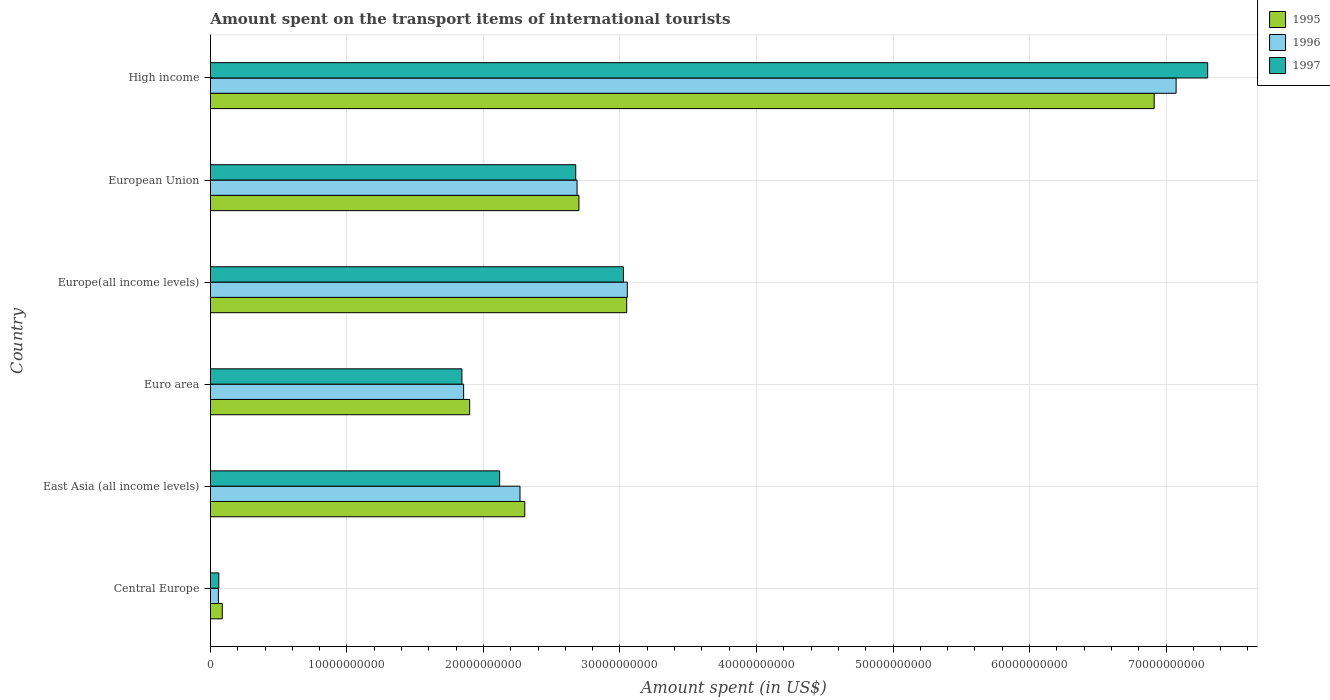Are the number of bars per tick equal to the number of legend labels?
Your response must be concise. Yes. How many bars are there on the 5th tick from the top?
Make the answer very short. 3. What is the label of the 5th group of bars from the top?
Your response must be concise. East Asia (all income levels). What is the amount spent on the transport items of international tourists in 1997 in Europe(all income levels)?
Keep it short and to the point. 3.03e+1. Across all countries, what is the maximum amount spent on the transport items of international tourists in 1996?
Give a very brief answer. 7.07e+1. Across all countries, what is the minimum amount spent on the transport items of international tourists in 1996?
Your answer should be compact. 5.81e+08. In which country was the amount spent on the transport items of international tourists in 1997 maximum?
Your answer should be compact. High income. In which country was the amount spent on the transport items of international tourists in 1996 minimum?
Your answer should be very brief. Central Europe. What is the total amount spent on the transport items of international tourists in 1995 in the graph?
Keep it short and to the point. 1.69e+11. What is the difference between the amount spent on the transport items of international tourists in 1995 in Europe(all income levels) and that in European Union?
Offer a very short reply. 3.50e+09. What is the difference between the amount spent on the transport items of international tourists in 1997 in Euro area and the amount spent on the transport items of international tourists in 1995 in High income?
Give a very brief answer. -5.07e+1. What is the average amount spent on the transport items of international tourists in 1997 per country?
Provide a short and direct response. 2.84e+1. What is the difference between the amount spent on the transport items of international tourists in 1997 and amount spent on the transport items of international tourists in 1996 in Europe(all income levels)?
Ensure brevity in your answer.  -2.85e+08. In how many countries, is the amount spent on the transport items of international tourists in 1997 greater than 48000000000 US$?
Your response must be concise. 1. What is the ratio of the amount spent on the transport items of international tourists in 1997 in Central Europe to that in High income?
Ensure brevity in your answer.  0.01. What is the difference between the highest and the second highest amount spent on the transport items of international tourists in 1995?
Offer a terse response. 3.86e+1. What is the difference between the highest and the lowest amount spent on the transport items of international tourists in 1996?
Your response must be concise. 7.02e+1. In how many countries, is the amount spent on the transport items of international tourists in 1997 greater than the average amount spent on the transport items of international tourists in 1997 taken over all countries?
Your answer should be compact. 2. What does the 2nd bar from the bottom in East Asia (all income levels) represents?
Your answer should be very brief. 1996. How many bars are there?
Ensure brevity in your answer.  18. How many countries are there in the graph?
Make the answer very short. 6. What is the difference between two consecutive major ticks on the X-axis?
Give a very brief answer. 1.00e+1. Does the graph contain any zero values?
Provide a succinct answer. No. Where does the legend appear in the graph?
Offer a terse response. Top right. How many legend labels are there?
Provide a short and direct response. 3. What is the title of the graph?
Keep it short and to the point. Amount spent on the transport items of international tourists. Does "1999" appear as one of the legend labels in the graph?
Give a very brief answer. No. What is the label or title of the X-axis?
Keep it short and to the point. Amount spent (in US$). What is the label or title of the Y-axis?
Ensure brevity in your answer.  Country. What is the Amount spent (in US$) in 1995 in Central Europe?
Offer a terse response. 8.65e+08. What is the Amount spent (in US$) of 1996 in Central Europe?
Offer a very short reply. 5.81e+08. What is the Amount spent (in US$) in 1997 in Central Europe?
Make the answer very short. 6.10e+08. What is the Amount spent (in US$) in 1995 in East Asia (all income levels)?
Give a very brief answer. 2.30e+1. What is the Amount spent (in US$) of 1996 in East Asia (all income levels)?
Your response must be concise. 2.27e+1. What is the Amount spent (in US$) in 1997 in East Asia (all income levels)?
Your response must be concise. 2.12e+1. What is the Amount spent (in US$) in 1995 in Euro area?
Offer a terse response. 1.90e+1. What is the Amount spent (in US$) in 1996 in Euro area?
Make the answer very short. 1.85e+1. What is the Amount spent (in US$) in 1997 in Euro area?
Keep it short and to the point. 1.84e+1. What is the Amount spent (in US$) of 1995 in Europe(all income levels)?
Your answer should be very brief. 3.05e+1. What is the Amount spent (in US$) in 1996 in Europe(all income levels)?
Offer a very short reply. 3.05e+1. What is the Amount spent (in US$) of 1997 in Europe(all income levels)?
Your answer should be very brief. 3.03e+1. What is the Amount spent (in US$) of 1995 in European Union?
Your answer should be compact. 2.70e+1. What is the Amount spent (in US$) in 1996 in European Union?
Ensure brevity in your answer.  2.69e+1. What is the Amount spent (in US$) of 1997 in European Union?
Your answer should be very brief. 2.68e+1. What is the Amount spent (in US$) of 1995 in High income?
Your answer should be very brief. 6.91e+1. What is the Amount spent (in US$) of 1996 in High income?
Provide a succinct answer. 7.07e+1. What is the Amount spent (in US$) in 1997 in High income?
Your response must be concise. 7.31e+1. Across all countries, what is the maximum Amount spent (in US$) in 1995?
Your answer should be compact. 6.91e+1. Across all countries, what is the maximum Amount spent (in US$) in 1996?
Give a very brief answer. 7.07e+1. Across all countries, what is the maximum Amount spent (in US$) in 1997?
Offer a very short reply. 7.31e+1. Across all countries, what is the minimum Amount spent (in US$) of 1995?
Your answer should be very brief. 8.65e+08. Across all countries, what is the minimum Amount spent (in US$) of 1996?
Make the answer very short. 5.81e+08. Across all countries, what is the minimum Amount spent (in US$) of 1997?
Offer a very short reply. 6.10e+08. What is the total Amount spent (in US$) of 1995 in the graph?
Provide a succinct answer. 1.69e+11. What is the total Amount spent (in US$) of 1996 in the graph?
Provide a succinct answer. 1.70e+11. What is the total Amount spent (in US$) of 1997 in the graph?
Provide a short and direct response. 1.70e+11. What is the difference between the Amount spent (in US$) in 1995 in Central Europe and that in East Asia (all income levels)?
Your answer should be compact. -2.22e+1. What is the difference between the Amount spent (in US$) of 1996 in Central Europe and that in East Asia (all income levels)?
Your response must be concise. -2.21e+1. What is the difference between the Amount spent (in US$) in 1997 in Central Europe and that in East Asia (all income levels)?
Provide a succinct answer. -2.06e+1. What is the difference between the Amount spent (in US$) in 1995 in Central Europe and that in Euro area?
Ensure brevity in your answer.  -1.81e+1. What is the difference between the Amount spent (in US$) in 1996 in Central Europe and that in Euro area?
Your answer should be compact. -1.80e+1. What is the difference between the Amount spent (in US$) of 1997 in Central Europe and that in Euro area?
Your response must be concise. -1.78e+1. What is the difference between the Amount spent (in US$) of 1995 in Central Europe and that in Europe(all income levels)?
Give a very brief answer. -2.96e+1. What is the difference between the Amount spent (in US$) in 1996 in Central Europe and that in Europe(all income levels)?
Offer a very short reply. -3.00e+1. What is the difference between the Amount spent (in US$) in 1997 in Central Europe and that in Europe(all income levels)?
Provide a short and direct response. -2.96e+1. What is the difference between the Amount spent (in US$) of 1995 in Central Europe and that in European Union?
Provide a short and direct response. -2.61e+1. What is the difference between the Amount spent (in US$) in 1996 in Central Europe and that in European Union?
Provide a short and direct response. -2.63e+1. What is the difference between the Amount spent (in US$) of 1997 in Central Europe and that in European Union?
Provide a short and direct response. -2.61e+1. What is the difference between the Amount spent (in US$) of 1995 in Central Europe and that in High income?
Your answer should be compact. -6.83e+1. What is the difference between the Amount spent (in US$) in 1996 in Central Europe and that in High income?
Your answer should be compact. -7.02e+1. What is the difference between the Amount spent (in US$) of 1997 in Central Europe and that in High income?
Your answer should be compact. -7.24e+1. What is the difference between the Amount spent (in US$) of 1995 in East Asia (all income levels) and that in Euro area?
Your answer should be very brief. 4.04e+09. What is the difference between the Amount spent (in US$) of 1996 in East Asia (all income levels) and that in Euro area?
Offer a terse response. 4.13e+09. What is the difference between the Amount spent (in US$) in 1997 in East Asia (all income levels) and that in Euro area?
Make the answer very short. 2.76e+09. What is the difference between the Amount spent (in US$) in 1995 in East Asia (all income levels) and that in Europe(all income levels)?
Provide a short and direct response. -7.47e+09. What is the difference between the Amount spent (in US$) of 1996 in East Asia (all income levels) and that in Europe(all income levels)?
Your answer should be very brief. -7.86e+09. What is the difference between the Amount spent (in US$) of 1997 in East Asia (all income levels) and that in Europe(all income levels)?
Make the answer very short. -9.07e+09. What is the difference between the Amount spent (in US$) of 1995 in East Asia (all income levels) and that in European Union?
Ensure brevity in your answer.  -3.97e+09. What is the difference between the Amount spent (in US$) of 1996 in East Asia (all income levels) and that in European Union?
Provide a short and direct response. -4.18e+09. What is the difference between the Amount spent (in US$) of 1997 in East Asia (all income levels) and that in European Union?
Make the answer very short. -5.57e+09. What is the difference between the Amount spent (in US$) in 1995 in East Asia (all income levels) and that in High income?
Your response must be concise. -4.61e+1. What is the difference between the Amount spent (in US$) in 1996 in East Asia (all income levels) and that in High income?
Make the answer very short. -4.81e+1. What is the difference between the Amount spent (in US$) in 1997 in East Asia (all income levels) and that in High income?
Ensure brevity in your answer.  -5.19e+1. What is the difference between the Amount spent (in US$) of 1995 in Euro area and that in Europe(all income levels)?
Provide a succinct answer. -1.15e+1. What is the difference between the Amount spent (in US$) of 1996 in Euro area and that in Europe(all income levels)?
Provide a succinct answer. -1.20e+1. What is the difference between the Amount spent (in US$) in 1997 in Euro area and that in Europe(all income levels)?
Keep it short and to the point. -1.18e+1. What is the difference between the Amount spent (in US$) in 1995 in Euro area and that in European Union?
Make the answer very short. -8.01e+09. What is the difference between the Amount spent (in US$) in 1996 in Euro area and that in European Union?
Give a very brief answer. -8.31e+09. What is the difference between the Amount spent (in US$) in 1997 in Euro area and that in European Union?
Your response must be concise. -8.34e+09. What is the difference between the Amount spent (in US$) in 1995 in Euro area and that in High income?
Offer a terse response. -5.01e+1. What is the difference between the Amount spent (in US$) in 1996 in Euro area and that in High income?
Your response must be concise. -5.22e+1. What is the difference between the Amount spent (in US$) of 1997 in Euro area and that in High income?
Your response must be concise. -5.46e+1. What is the difference between the Amount spent (in US$) in 1995 in Europe(all income levels) and that in European Union?
Give a very brief answer. 3.50e+09. What is the difference between the Amount spent (in US$) in 1996 in Europe(all income levels) and that in European Union?
Ensure brevity in your answer.  3.68e+09. What is the difference between the Amount spent (in US$) in 1997 in Europe(all income levels) and that in European Union?
Offer a very short reply. 3.49e+09. What is the difference between the Amount spent (in US$) in 1995 in Europe(all income levels) and that in High income?
Your answer should be very brief. -3.86e+1. What is the difference between the Amount spent (in US$) in 1996 in Europe(all income levels) and that in High income?
Your response must be concise. -4.02e+1. What is the difference between the Amount spent (in US$) in 1997 in Europe(all income levels) and that in High income?
Your response must be concise. -4.28e+1. What is the difference between the Amount spent (in US$) of 1995 in European Union and that in High income?
Keep it short and to the point. -4.21e+1. What is the difference between the Amount spent (in US$) in 1996 in European Union and that in High income?
Make the answer very short. -4.39e+1. What is the difference between the Amount spent (in US$) of 1997 in European Union and that in High income?
Offer a terse response. -4.63e+1. What is the difference between the Amount spent (in US$) of 1995 in Central Europe and the Amount spent (in US$) of 1996 in East Asia (all income levels)?
Your answer should be very brief. -2.18e+1. What is the difference between the Amount spent (in US$) in 1995 in Central Europe and the Amount spent (in US$) in 1997 in East Asia (all income levels)?
Keep it short and to the point. -2.03e+1. What is the difference between the Amount spent (in US$) in 1996 in Central Europe and the Amount spent (in US$) in 1997 in East Asia (all income levels)?
Give a very brief answer. -2.06e+1. What is the difference between the Amount spent (in US$) in 1995 in Central Europe and the Amount spent (in US$) in 1996 in Euro area?
Your answer should be very brief. -1.77e+1. What is the difference between the Amount spent (in US$) of 1995 in Central Europe and the Amount spent (in US$) of 1997 in Euro area?
Give a very brief answer. -1.76e+1. What is the difference between the Amount spent (in US$) of 1996 in Central Europe and the Amount spent (in US$) of 1997 in Euro area?
Give a very brief answer. -1.78e+1. What is the difference between the Amount spent (in US$) in 1995 in Central Europe and the Amount spent (in US$) in 1996 in Europe(all income levels)?
Offer a terse response. -2.97e+1. What is the difference between the Amount spent (in US$) of 1995 in Central Europe and the Amount spent (in US$) of 1997 in Europe(all income levels)?
Your response must be concise. -2.94e+1. What is the difference between the Amount spent (in US$) in 1996 in Central Europe and the Amount spent (in US$) in 1997 in Europe(all income levels)?
Keep it short and to the point. -2.97e+1. What is the difference between the Amount spent (in US$) of 1995 in Central Europe and the Amount spent (in US$) of 1996 in European Union?
Provide a short and direct response. -2.60e+1. What is the difference between the Amount spent (in US$) in 1995 in Central Europe and the Amount spent (in US$) in 1997 in European Union?
Your response must be concise. -2.59e+1. What is the difference between the Amount spent (in US$) in 1996 in Central Europe and the Amount spent (in US$) in 1997 in European Union?
Keep it short and to the point. -2.62e+1. What is the difference between the Amount spent (in US$) of 1995 in Central Europe and the Amount spent (in US$) of 1996 in High income?
Give a very brief answer. -6.99e+1. What is the difference between the Amount spent (in US$) in 1995 in Central Europe and the Amount spent (in US$) in 1997 in High income?
Offer a terse response. -7.22e+1. What is the difference between the Amount spent (in US$) of 1996 in Central Europe and the Amount spent (in US$) of 1997 in High income?
Provide a short and direct response. -7.25e+1. What is the difference between the Amount spent (in US$) of 1995 in East Asia (all income levels) and the Amount spent (in US$) of 1996 in Euro area?
Make the answer very short. 4.48e+09. What is the difference between the Amount spent (in US$) of 1995 in East Asia (all income levels) and the Amount spent (in US$) of 1997 in Euro area?
Offer a very short reply. 4.61e+09. What is the difference between the Amount spent (in US$) of 1996 in East Asia (all income levels) and the Amount spent (in US$) of 1997 in Euro area?
Offer a terse response. 4.26e+09. What is the difference between the Amount spent (in US$) of 1995 in East Asia (all income levels) and the Amount spent (in US$) of 1996 in Europe(all income levels)?
Give a very brief answer. -7.51e+09. What is the difference between the Amount spent (in US$) of 1995 in East Asia (all income levels) and the Amount spent (in US$) of 1997 in Europe(all income levels)?
Keep it short and to the point. -7.23e+09. What is the difference between the Amount spent (in US$) in 1996 in East Asia (all income levels) and the Amount spent (in US$) in 1997 in Europe(all income levels)?
Keep it short and to the point. -7.58e+09. What is the difference between the Amount spent (in US$) of 1995 in East Asia (all income levels) and the Amount spent (in US$) of 1996 in European Union?
Give a very brief answer. -3.83e+09. What is the difference between the Amount spent (in US$) of 1995 in East Asia (all income levels) and the Amount spent (in US$) of 1997 in European Union?
Your answer should be compact. -3.73e+09. What is the difference between the Amount spent (in US$) of 1996 in East Asia (all income levels) and the Amount spent (in US$) of 1997 in European Union?
Provide a short and direct response. -4.08e+09. What is the difference between the Amount spent (in US$) in 1995 in East Asia (all income levels) and the Amount spent (in US$) in 1996 in High income?
Provide a succinct answer. -4.77e+1. What is the difference between the Amount spent (in US$) of 1995 in East Asia (all income levels) and the Amount spent (in US$) of 1997 in High income?
Ensure brevity in your answer.  -5.00e+1. What is the difference between the Amount spent (in US$) of 1996 in East Asia (all income levels) and the Amount spent (in US$) of 1997 in High income?
Make the answer very short. -5.04e+1. What is the difference between the Amount spent (in US$) of 1995 in Euro area and the Amount spent (in US$) of 1996 in Europe(all income levels)?
Ensure brevity in your answer.  -1.15e+1. What is the difference between the Amount spent (in US$) of 1995 in Euro area and the Amount spent (in US$) of 1997 in Europe(all income levels)?
Offer a very short reply. -1.13e+1. What is the difference between the Amount spent (in US$) in 1996 in Euro area and the Amount spent (in US$) in 1997 in Europe(all income levels)?
Your answer should be compact. -1.17e+1. What is the difference between the Amount spent (in US$) in 1995 in Euro area and the Amount spent (in US$) in 1996 in European Union?
Make the answer very short. -7.87e+09. What is the difference between the Amount spent (in US$) in 1995 in Euro area and the Amount spent (in US$) in 1997 in European Union?
Offer a terse response. -7.77e+09. What is the difference between the Amount spent (in US$) in 1996 in Euro area and the Amount spent (in US$) in 1997 in European Union?
Ensure brevity in your answer.  -8.21e+09. What is the difference between the Amount spent (in US$) of 1995 in Euro area and the Amount spent (in US$) of 1996 in High income?
Give a very brief answer. -5.18e+1. What is the difference between the Amount spent (in US$) in 1995 in Euro area and the Amount spent (in US$) in 1997 in High income?
Provide a short and direct response. -5.41e+1. What is the difference between the Amount spent (in US$) in 1996 in Euro area and the Amount spent (in US$) in 1997 in High income?
Provide a succinct answer. -5.45e+1. What is the difference between the Amount spent (in US$) in 1995 in Europe(all income levels) and the Amount spent (in US$) in 1996 in European Union?
Offer a very short reply. 3.63e+09. What is the difference between the Amount spent (in US$) of 1995 in Europe(all income levels) and the Amount spent (in US$) of 1997 in European Union?
Provide a succinct answer. 3.73e+09. What is the difference between the Amount spent (in US$) in 1996 in Europe(all income levels) and the Amount spent (in US$) in 1997 in European Union?
Your answer should be compact. 3.78e+09. What is the difference between the Amount spent (in US$) in 1995 in Europe(all income levels) and the Amount spent (in US$) in 1996 in High income?
Keep it short and to the point. -4.02e+1. What is the difference between the Amount spent (in US$) of 1995 in Europe(all income levels) and the Amount spent (in US$) of 1997 in High income?
Your response must be concise. -4.26e+1. What is the difference between the Amount spent (in US$) of 1996 in Europe(all income levels) and the Amount spent (in US$) of 1997 in High income?
Keep it short and to the point. -4.25e+1. What is the difference between the Amount spent (in US$) in 1995 in European Union and the Amount spent (in US$) in 1996 in High income?
Provide a short and direct response. -4.37e+1. What is the difference between the Amount spent (in US$) of 1995 in European Union and the Amount spent (in US$) of 1997 in High income?
Give a very brief answer. -4.61e+1. What is the difference between the Amount spent (in US$) of 1996 in European Union and the Amount spent (in US$) of 1997 in High income?
Offer a very short reply. -4.62e+1. What is the average Amount spent (in US$) in 1995 per country?
Your answer should be compact. 2.82e+1. What is the average Amount spent (in US$) of 1996 per country?
Provide a short and direct response. 2.83e+1. What is the average Amount spent (in US$) in 1997 per country?
Ensure brevity in your answer.  2.84e+1. What is the difference between the Amount spent (in US$) in 1995 and Amount spent (in US$) in 1996 in Central Europe?
Your answer should be compact. 2.85e+08. What is the difference between the Amount spent (in US$) in 1995 and Amount spent (in US$) in 1997 in Central Europe?
Your response must be concise. 2.55e+08. What is the difference between the Amount spent (in US$) in 1996 and Amount spent (in US$) in 1997 in Central Europe?
Offer a very short reply. -2.91e+07. What is the difference between the Amount spent (in US$) of 1995 and Amount spent (in US$) of 1996 in East Asia (all income levels)?
Your response must be concise. 3.50e+08. What is the difference between the Amount spent (in US$) in 1995 and Amount spent (in US$) in 1997 in East Asia (all income levels)?
Your answer should be very brief. 1.84e+09. What is the difference between the Amount spent (in US$) of 1996 and Amount spent (in US$) of 1997 in East Asia (all income levels)?
Your response must be concise. 1.49e+09. What is the difference between the Amount spent (in US$) of 1995 and Amount spent (in US$) of 1996 in Euro area?
Give a very brief answer. 4.42e+08. What is the difference between the Amount spent (in US$) of 1995 and Amount spent (in US$) of 1997 in Euro area?
Offer a very short reply. 5.69e+08. What is the difference between the Amount spent (in US$) in 1996 and Amount spent (in US$) in 1997 in Euro area?
Provide a succinct answer. 1.27e+08. What is the difference between the Amount spent (in US$) of 1995 and Amount spent (in US$) of 1996 in Europe(all income levels)?
Make the answer very short. -4.44e+07. What is the difference between the Amount spent (in US$) in 1995 and Amount spent (in US$) in 1997 in Europe(all income levels)?
Make the answer very short. 2.41e+08. What is the difference between the Amount spent (in US$) of 1996 and Amount spent (in US$) of 1997 in Europe(all income levels)?
Offer a very short reply. 2.85e+08. What is the difference between the Amount spent (in US$) in 1995 and Amount spent (in US$) in 1996 in European Union?
Provide a short and direct response. 1.37e+08. What is the difference between the Amount spent (in US$) in 1995 and Amount spent (in US$) in 1997 in European Union?
Give a very brief answer. 2.35e+08. What is the difference between the Amount spent (in US$) of 1996 and Amount spent (in US$) of 1997 in European Union?
Provide a succinct answer. 9.81e+07. What is the difference between the Amount spent (in US$) in 1995 and Amount spent (in US$) in 1996 in High income?
Offer a terse response. -1.61e+09. What is the difference between the Amount spent (in US$) in 1995 and Amount spent (in US$) in 1997 in High income?
Ensure brevity in your answer.  -3.92e+09. What is the difference between the Amount spent (in US$) in 1996 and Amount spent (in US$) in 1997 in High income?
Your answer should be very brief. -2.31e+09. What is the ratio of the Amount spent (in US$) in 1995 in Central Europe to that in East Asia (all income levels)?
Offer a very short reply. 0.04. What is the ratio of the Amount spent (in US$) in 1996 in Central Europe to that in East Asia (all income levels)?
Your answer should be compact. 0.03. What is the ratio of the Amount spent (in US$) of 1997 in Central Europe to that in East Asia (all income levels)?
Offer a very short reply. 0.03. What is the ratio of the Amount spent (in US$) in 1995 in Central Europe to that in Euro area?
Offer a very short reply. 0.05. What is the ratio of the Amount spent (in US$) of 1996 in Central Europe to that in Euro area?
Provide a short and direct response. 0.03. What is the ratio of the Amount spent (in US$) in 1997 in Central Europe to that in Euro area?
Provide a succinct answer. 0.03. What is the ratio of the Amount spent (in US$) in 1995 in Central Europe to that in Europe(all income levels)?
Keep it short and to the point. 0.03. What is the ratio of the Amount spent (in US$) in 1996 in Central Europe to that in Europe(all income levels)?
Your answer should be very brief. 0.02. What is the ratio of the Amount spent (in US$) of 1997 in Central Europe to that in Europe(all income levels)?
Offer a terse response. 0.02. What is the ratio of the Amount spent (in US$) of 1995 in Central Europe to that in European Union?
Your answer should be very brief. 0.03. What is the ratio of the Amount spent (in US$) of 1996 in Central Europe to that in European Union?
Offer a very short reply. 0.02. What is the ratio of the Amount spent (in US$) of 1997 in Central Europe to that in European Union?
Offer a terse response. 0.02. What is the ratio of the Amount spent (in US$) of 1995 in Central Europe to that in High income?
Offer a very short reply. 0.01. What is the ratio of the Amount spent (in US$) in 1996 in Central Europe to that in High income?
Ensure brevity in your answer.  0.01. What is the ratio of the Amount spent (in US$) in 1997 in Central Europe to that in High income?
Your answer should be very brief. 0.01. What is the ratio of the Amount spent (in US$) in 1995 in East Asia (all income levels) to that in Euro area?
Make the answer very short. 1.21. What is the ratio of the Amount spent (in US$) of 1996 in East Asia (all income levels) to that in Euro area?
Offer a terse response. 1.22. What is the ratio of the Amount spent (in US$) of 1997 in East Asia (all income levels) to that in Euro area?
Make the answer very short. 1.15. What is the ratio of the Amount spent (in US$) in 1995 in East Asia (all income levels) to that in Europe(all income levels)?
Keep it short and to the point. 0.76. What is the ratio of the Amount spent (in US$) in 1996 in East Asia (all income levels) to that in Europe(all income levels)?
Provide a short and direct response. 0.74. What is the ratio of the Amount spent (in US$) of 1997 in East Asia (all income levels) to that in Europe(all income levels)?
Provide a short and direct response. 0.7. What is the ratio of the Amount spent (in US$) in 1995 in East Asia (all income levels) to that in European Union?
Make the answer very short. 0.85. What is the ratio of the Amount spent (in US$) in 1996 in East Asia (all income levels) to that in European Union?
Offer a very short reply. 0.84. What is the ratio of the Amount spent (in US$) in 1997 in East Asia (all income levels) to that in European Union?
Give a very brief answer. 0.79. What is the ratio of the Amount spent (in US$) in 1995 in East Asia (all income levels) to that in High income?
Make the answer very short. 0.33. What is the ratio of the Amount spent (in US$) of 1996 in East Asia (all income levels) to that in High income?
Give a very brief answer. 0.32. What is the ratio of the Amount spent (in US$) of 1997 in East Asia (all income levels) to that in High income?
Ensure brevity in your answer.  0.29. What is the ratio of the Amount spent (in US$) of 1995 in Euro area to that in Europe(all income levels)?
Provide a short and direct response. 0.62. What is the ratio of the Amount spent (in US$) of 1996 in Euro area to that in Europe(all income levels)?
Make the answer very short. 0.61. What is the ratio of the Amount spent (in US$) of 1997 in Euro area to that in Europe(all income levels)?
Keep it short and to the point. 0.61. What is the ratio of the Amount spent (in US$) of 1995 in Euro area to that in European Union?
Your answer should be very brief. 0.7. What is the ratio of the Amount spent (in US$) in 1996 in Euro area to that in European Union?
Your answer should be very brief. 0.69. What is the ratio of the Amount spent (in US$) in 1997 in Euro area to that in European Union?
Make the answer very short. 0.69. What is the ratio of the Amount spent (in US$) in 1995 in Euro area to that in High income?
Ensure brevity in your answer.  0.27. What is the ratio of the Amount spent (in US$) of 1996 in Euro area to that in High income?
Offer a very short reply. 0.26. What is the ratio of the Amount spent (in US$) in 1997 in Euro area to that in High income?
Keep it short and to the point. 0.25. What is the ratio of the Amount spent (in US$) in 1995 in Europe(all income levels) to that in European Union?
Give a very brief answer. 1.13. What is the ratio of the Amount spent (in US$) of 1996 in Europe(all income levels) to that in European Union?
Provide a short and direct response. 1.14. What is the ratio of the Amount spent (in US$) of 1997 in Europe(all income levels) to that in European Union?
Offer a very short reply. 1.13. What is the ratio of the Amount spent (in US$) in 1995 in Europe(all income levels) to that in High income?
Give a very brief answer. 0.44. What is the ratio of the Amount spent (in US$) of 1996 in Europe(all income levels) to that in High income?
Provide a succinct answer. 0.43. What is the ratio of the Amount spent (in US$) of 1997 in Europe(all income levels) to that in High income?
Make the answer very short. 0.41. What is the ratio of the Amount spent (in US$) in 1995 in European Union to that in High income?
Offer a terse response. 0.39. What is the ratio of the Amount spent (in US$) in 1996 in European Union to that in High income?
Offer a terse response. 0.38. What is the ratio of the Amount spent (in US$) of 1997 in European Union to that in High income?
Ensure brevity in your answer.  0.37. What is the difference between the highest and the second highest Amount spent (in US$) of 1995?
Your response must be concise. 3.86e+1. What is the difference between the highest and the second highest Amount spent (in US$) of 1996?
Provide a succinct answer. 4.02e+1. What is the difference between the highest and the second highest Amount spent (in US$) of 1997?
Your answer should be compact. 4.28e+1. What is the difference between the highest and the lowest Amount spent (in US$) of 1995?
Keep it short and to the point. 6.83e+1. What is the difference between the highest and the lowest Amount spent (in US$) in 1996?
Provide a short and direct response. 7.02e+1. What is the difference between the highest and the lowest Amount spent (in US$) in 1997?
Offer a terse response. 7.24e+1. 